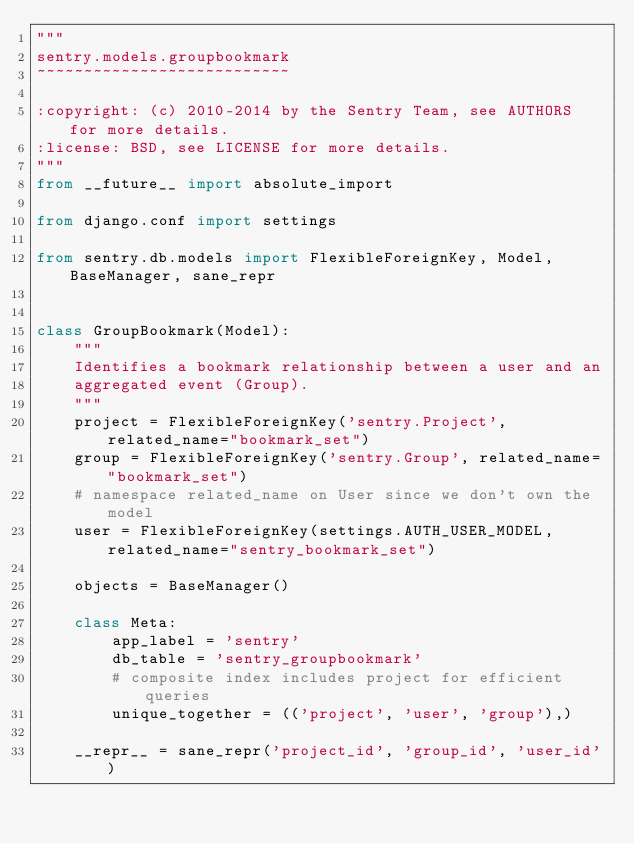<code> <loc_0><loc_0><loc_500><loc_500><_Python_>"""
sentry.models.groupbookmark
~~~~~~~~~~~~~~~~~~~~~~~~~~~

:copyright: (c) 2010-2014 by the Sentry Team, see AUTHORS for more details.
:license: BSD, see LICENSE for more details.
"""
from __future__ import absolute_import

from django.conf import settings

from sentry.db.models import FlexibleForeignKey, Model, BaseManager, sane_repr


class GroupBookmark(Model):
    """
    Identifies a bookmark relationship between a user and an
    aggregated event (Group).
    """
    project = FlexibleForeignKey('sentry.Project', related_name="bookmark_set")
    group = FlexibleForeignKey('sentry.Group', related_name="bookmark_set")
    # namespace related_name on User since we don't own the model
    user = FlexibleForeignKey(settings.AUTH_USER_MODEL, related_name="sentry_bookmark_set")

    objects = BaseManager()

    class Meta:
        app_label = 'sentry'
        db_table = 'sentry_groupbookmark'
        # composite index includes project for efficient queries
        unique_together = (('project', 'user', 'group'),)

    __repr__ = sane_repr('project_id', 'group_id', 'user_id')
</code> 